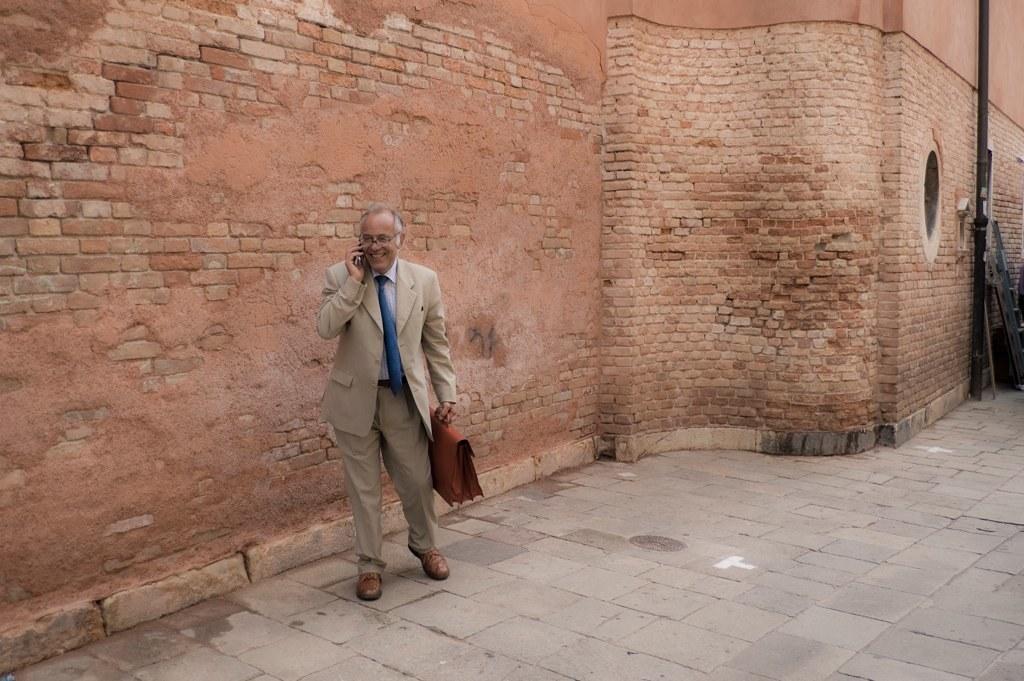In one or two sentences, can you explain what this image depicts? In the middle of the image a person is walking and holding a mobile phone and bag. Behind him there is a wall and pole. 